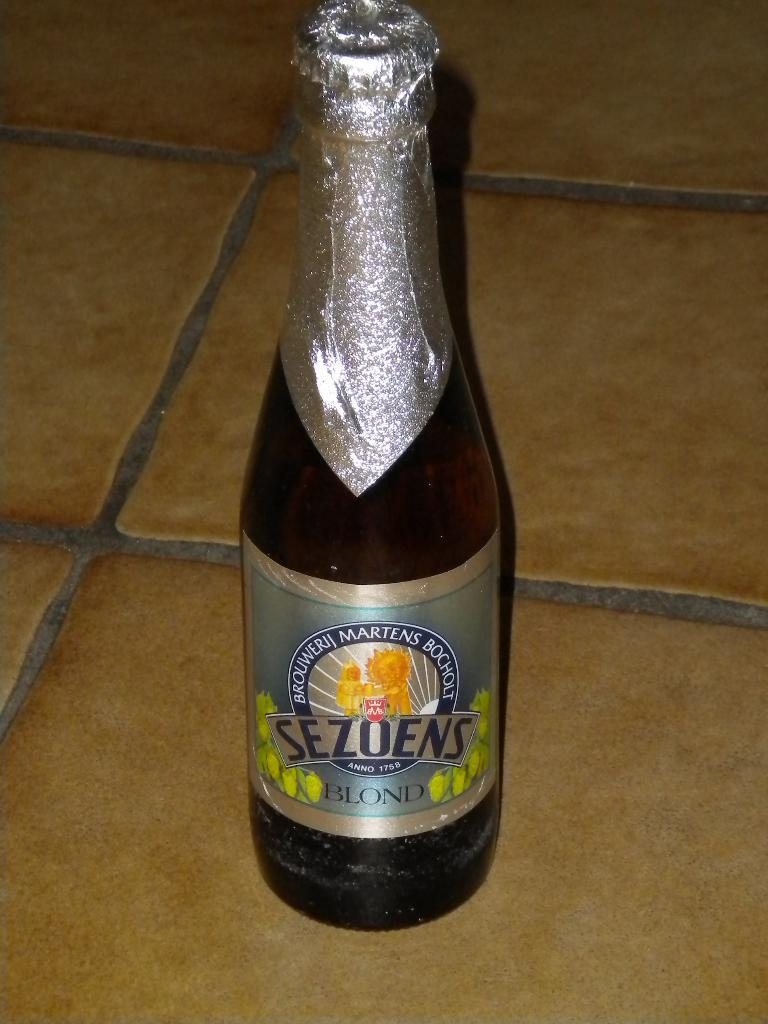<image>
Summarize the visual content of the image. An unopened bottle of Sezoens Blond beer on a tile surface. 